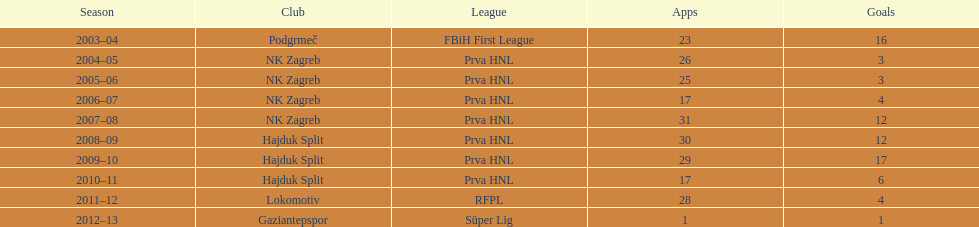Which team has scored the most goals? Hajduk Split. 